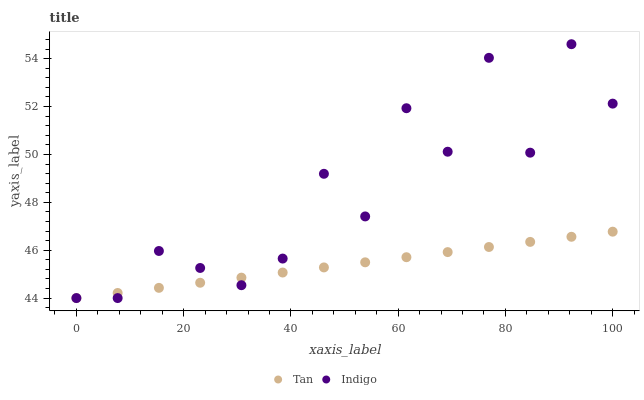Does Tan have the minimum area under the curve?
Answer yes or no. Yes. Does Indigo have the maximum area under the curve?
Answer yes or no. Yes. Does Indigo have the minimum area under the curve?
Answer yes or no. No. Is Tan the smoothest?
Answer yes or no. Yes. Is Indigo the roughest?
Answer yes or no. Yes. Is Indigo the smoothest?
Answer yes or no. No. Does Tan have the lowest value?
Answer yes or no. Yes. Does Indigo have the highest value?
Answer yes or no. Yes. Does Indigo intersect Tan?
Answer yes or no. Yes. Is Indigo less than Tan?
Answer yes or no. No. Is Indigo greater than Tan?
Answer yes or no. No. 